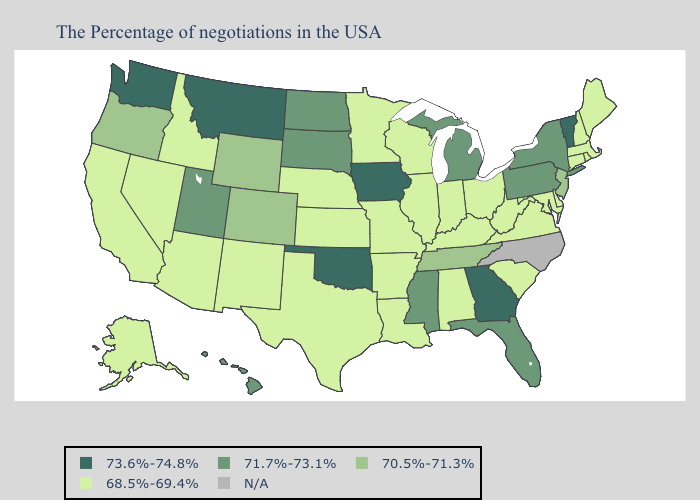Name the states that have a value in the range N/A?
Concise answer only. North Carolina. Name the states that have a value in the range 71.7%-73.1%?
Quick response, please. New York, Pennsylvania, Florida, Michigan, Mississippi, South Dakota, North Dakota, Utah, Hawaii. Does West Virginia have the lowest value in the South?
Quick response, please. Yes. Name the states that have a value in the range 70.5%-71.3%?
Keep it brief. New Jersey, Tennessee, Wyoming, Colorado, Oregon. What is the value of California?
Keep it brief. 68.5%-69.4%. Which states hav the highest value in the Northeast?
Keep it brief. Vermont. What is the highest value in states that border Michigan?
Short answer required. 68.5%-69.4%. Is the legend a continuous bar?
Be succinct. No. How many symbols are there in the legend?
Short answer required. 5. Among the states that border Mississippi , which have the lowest value?
Write a very short answer. Alabama, Louisiana, Arkansas. What is the highest value in the West ?
Concise answer only. 73.6%-74.8%. What is the highest value in states that border Mississippi?
Keep it brief. 70.5%-71.3%. What is the lowest value in the West?
Short answer required. 68.5%-69.4%. Does Illinois have the lowest value in the USA?
Answer briefly. Yes. What is the value of Florida?
Be succinct. 71.7%-73.1%. 